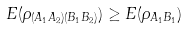Convert formula to latex. <formula><loc_0><loc_0><loc_500><loc_500>E ( \rho _ { ( A _ { 1 } A _ { 2 } ) ( B _ { 1 } B _ { 2 } ) } ) & \geq E ( \rho _ { A _ { 1 } B _ { 1 } } )</formula> 